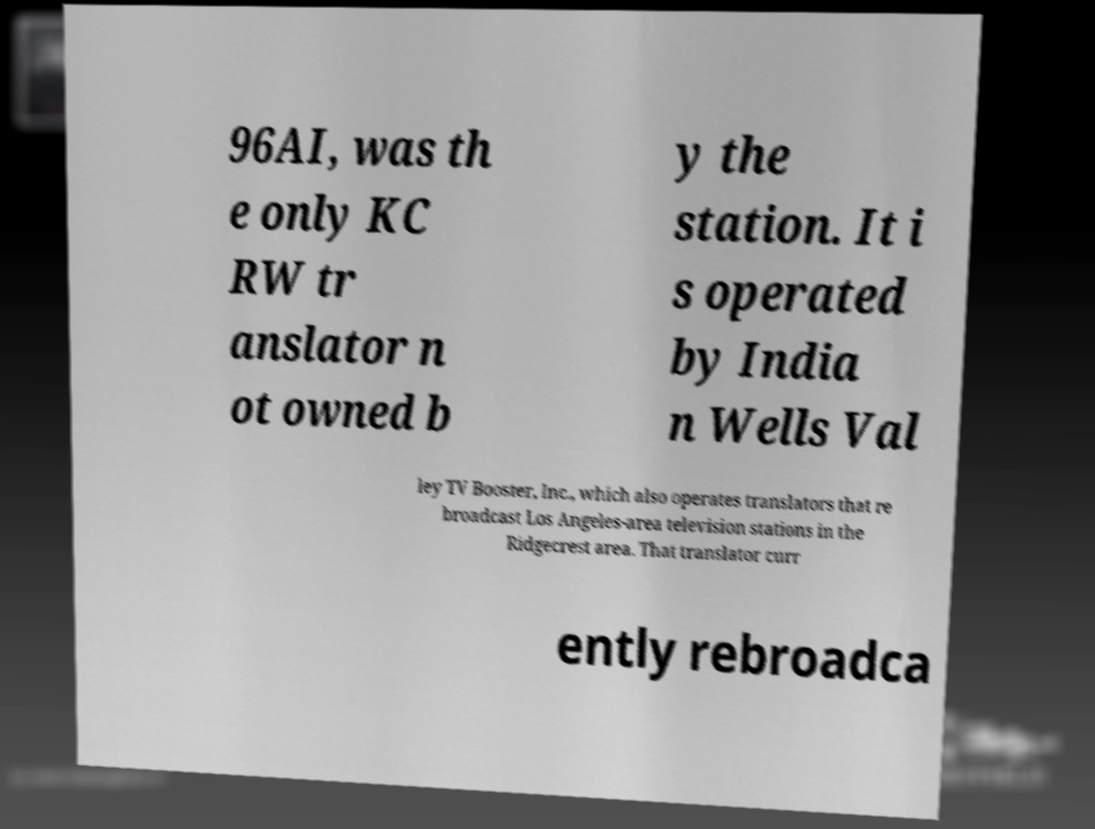What messages or text are displayed in this image? I need them in a readable, typed format. 96AI, was th e only KC RW tr anslator n ot owned b y the station. It i s operated by India n Wells Val ley TV Booster, Inc., which also operates translators that re broadcast Los Angeles-area television stations in the Ridgecrest area. That translator curr ently rebroadca 